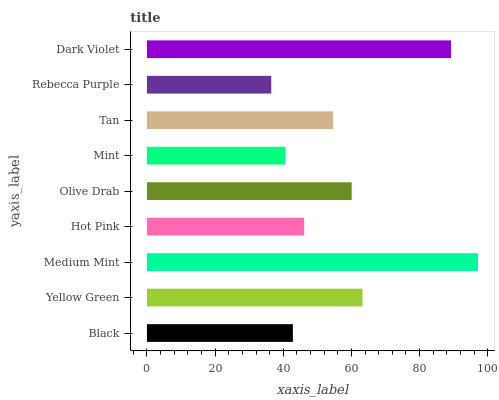Is Rebecca Purple the minimum?
Answer yes or no. Yes. Is Medium Mint the maximum?
Answer yes or no. Yes. Is Yellow Green the minimum?
Answer yes or no. No. Is Yellow Green the maximum?
Answer yes or no. No. Is Yellow Green greater than Black?
Answer yes or no. Yes. Is Black less than Yellow Green?
Answer yes or no. Yes. Is Black greater than Yellow Green?
Answer yes or no. No. Is Yellow Green less than Black?
Answer yes or no. No. Is Tan the high median?
Answer yes or no. Yes. Is Tan the low median?
Answer yes or no. Yes. Is Medium Mint the high median?
Answer yes or no. No. Is Hot Pink the low median?
Answer yes or no. No. 